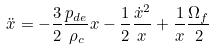Convert formula to latex. <formula><loc_0><loc_0><loc_500><loc_500>\ddot { x } = - \frac { 3 } { 2 } \frac { p _ { d e } } { \rho _ { c } } x - \frac { 1 } { 2 } \frac { { \dot { x } } ^ { 2 } } { x } + \frac { 1 } { x } \frac { \Omega _ { f } } { 2 }</formula> 